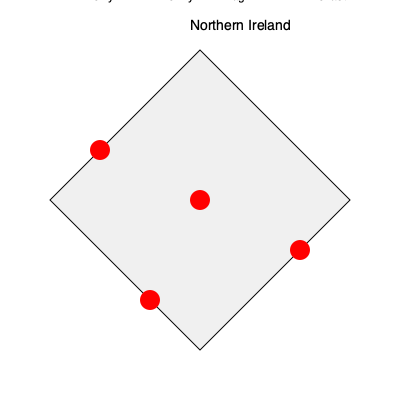Based on the map of Northern Ireland, which city marked in red was known as the "murder triangle" during the Troubles due to its high concentration of sectarian violence? To answer this question, we need to consider the following steps:

1. Identify the cities marked on the map: Derry, Belfast, Armagh, and Newry.

2. Recall the historical context of the Troubles:
   - The Troubles was a period of conflict in Northern Ireland from the late 1960s to 1998.
   - It involved violence between nationalist (mainly Catholic) and unionist (mainly Protestant) communities.

3. Understand the term "murder triangle":
   - This term was used to describe an area with a particularly high concentration of sectarian killings during the Troubles.

4. Analyze the geographical location and historical significance of each city:
   - Derry: Site of significant events like Bloody Sunday, but not referred to as the "murder triangle".
   - Belfast: The capital and largest city, experienced much violence but not known as the "murder triangle".
   - Armagh: Located in south Ulster, this area was indeed referred to as the "murder triangle".
   - Newry: While it experienced violence, it was not known as the "murder triangle".

5. Conclude that Armagh, located in the center of the map, corresponds to the area known as the "murder triangle" during the Troubles.
Answer: Armagh 